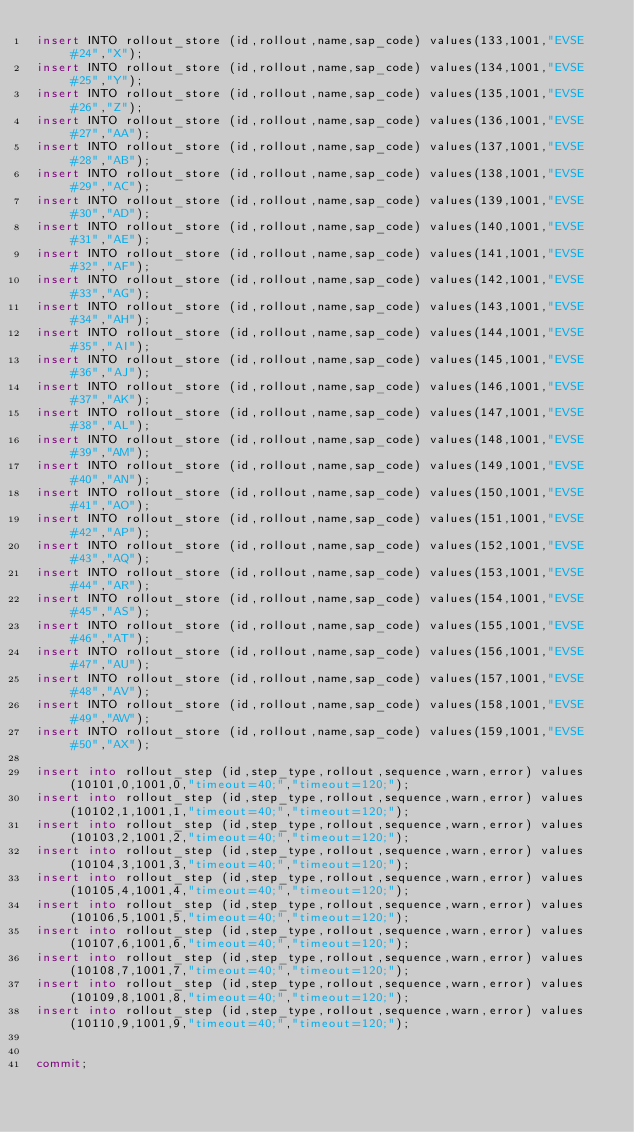<code> <loc_0><loc_0><loc_500><loc_500><_SQL_>insert INTO rollout_store (id,rollout,name,sap_code) values(133,1001,"EVSE #24","X");
insert INTO rollout_store (id,rollout,name,sap_code) values(134,1001,"EVSE #25","Y");
insert INTO rollout_store (id,rollout,name,sap_code) values(135,1001,"EVSE #26","Z");
insert INTO rollout_store (id,rollout,name,sap_code) values(136,1001,"EVSE #27","AA");
insert INTO rollout_store (id,rollout,name,sap_code) values(137,1001,"EVSE #28","AB");
insert INTO rollout_store (id,rollout,name,sap_code) values(138,1001,"EVSE #29","AC");
insert INTO rollout_store (id,rollout,name,sap_code) values(139,1001,"EVSE #30","AD");
insert INTO rollout_store (id,rollout,name,sap_code) values(140,1001,"EVSE #31","AE");
insert INTO rollout_store (id,rollout,name,sap_code) values(141,1001,"EVSE #32","AF");
insert INTO rollout_store (id,rollout,name,sap_code) values(142,1001,"EVSE #33","AG");
insert INTO rollout_store (id,rollout,name,sap_code) values(143,1001,"EVSE #34","AH");
insert INTO rollout_store (id,rollout,name,sap_code) values(144,1001,"EVSE #35","AI");
insert INTO rollout_store (id,rollout,name,sap_code) values(145,1001,"EVSE #36","AJ");
insert INTO rollout_store (id,rollout,name,sap_code) values(146,1001,"EVSE #37","AK");
insert INTO rollout_store (id,rollout,name,sap_code) values(147,1001,"EVSE #38","AL");
insert INTO rollout_store (id,rollout,name,sap_code) values(148,1001,"EVSE #39","AM");
insert INTO rollout_store (id,rollout,name,sap_code) values(149,1001,"EVSE #40","AN");
insert INTO rollout_store (id,rollout,name,sap_code) values(150,1001,"EVSE #41","AO");
insert INTO rollout_store (id,rollout,name,sap_code) values(151,1001,"EVSE #42","AP");
insert INTO rollout_store (id,rollout,name,sap_code) values(152,1001,"EVSE #43","AQ");
insert INTO rollout_store (id,rollout,name,sap_code) values(153,1001,"EVSE #44","AR");
insert INTO rollout_store (id,rollout,name,sap_code) values(154,1001,"EVSE #45","AS");
insert INTO rollout_store (id,rollout,name,sap_code) values(155,1001,"EVSE #46","AT");
insert INTO rollout_store (id,rollout,name,sap_code) values(156,1001,"EVSE #47","AU");
insert INTO rollout_store (id,rollout,name,sap_code) values(157,1001,"EVSE #48","AV");
insert INTO rollout_store (id,rollout,name,sap_code) values(158,1001,"EVSE #49","AW");
insert INTO rollout_store (id,rollout,name,sap_code) values(159,1001,"EVSE #50","AX");

insert into rollout_step (id,step_type,rollout,sequence,warn,error) values(10101,0,1001,0,"timeout=40;","timeout=120;");
insert into rollout_step (id,step_type,rollout,sequence,warn,error) values(10102,1,1001,1,"timeout=40;","timeout=120;");
insert into rollout_step (id,step_type,rollout,sequence,warn,error) values(10103,2,1001,2,"timeout=40;","timeout=120;");
insert into rollout_step (id,step_type,rollout,sequence,warn,error) values(10104,3,1001,3,"timeout=40;","timeout=120;");
insert into rollout_step (id,step_type,rollout,sequence,warn,error) values(10105,4,1001,4,"timeout=40;","timeout=120;");
insert into rollout_step (id,step_type,rollout,sequence,warn,error) values(10106,5,1001,5,"timeout=40;","timeout=120;");
insert into rollout_step (id,step_type,rollout,sequence,warn,error) values(10107,6,1001,6,"timeout=40;","timeout=120;");
insert into rollout_step (id,step_type,rollout,sequence,warn,error) values(10108,7,1001,7,"timeout=40;","timeout=120;");
insert into rollout_step (id,step_type,rollout,sequence,warn,error) values(10109,8,1001,8,"timeout=40;","timeout=120;");
insert into rollout_step (id,step_type,rollout,sequence,warn,error) values(10110,9,1001,9,"timeout=40;","timeout=120;");


commit;
</code> 